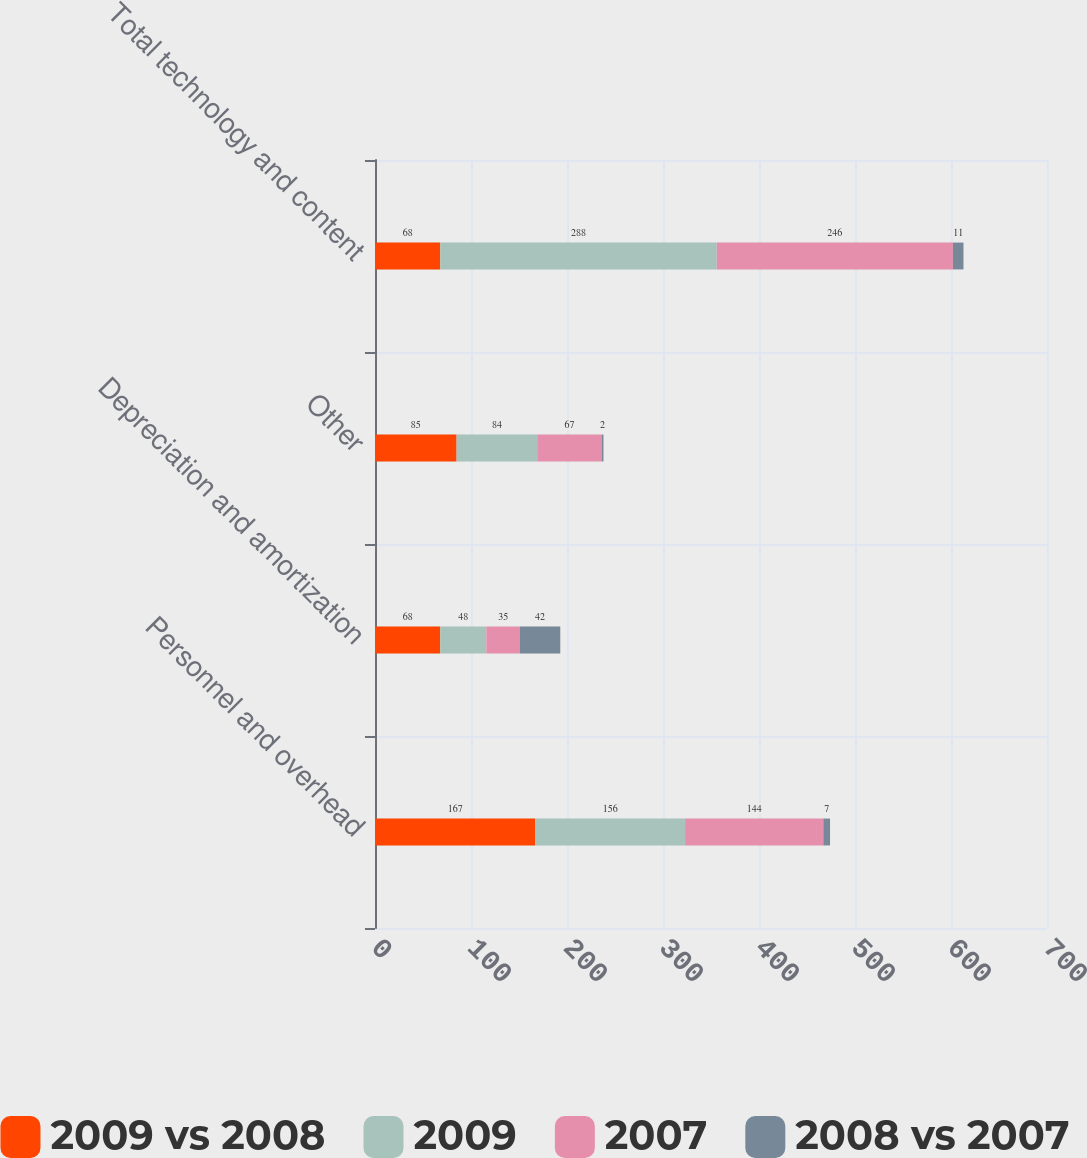Convert chart to OTSL. <chart><loc_0><loc_0><loc_500><loc_500><stacked_bar_chart><ecel><fcel>Personnel and overhead<fcel>Depreciation and amortization<fcel>Other<fcel>Total technology and content<nl><fcel>2009 vs 2008<fcel>167<fcel>68<fcel>85<fcel>68<nl><fcel>2009<fcel>156<fcel>48<fcel>84<fcel>288<nl><fcel>2007<fcel>144<fcel>35<fcel>67<fcel>246<nl><fcel>2008 vs 2007<fcel>7<fcel>42<fcel>2<fcel>11<nl></chart> 